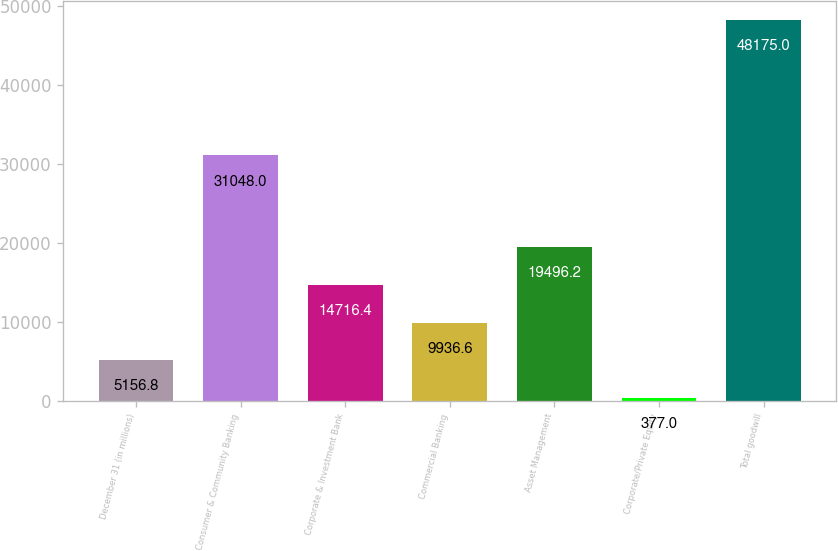<chart> <loc_0><loc_0><loc_500><loc_500><bar_chart><fcel>December 31 (in millions)<fcel>Consumer & Community Banking<fcel>Corporate & Investment Bank<fcel>Commercial Banking<fcel>Asset Management<fcel>Corporate/Private Equity<fcel>Total goodwill<nl><fcel>5156.8<fcel>31048<fcel>14716.4<fcel>9936.6<fcel>19496.2<fcel>377<fcel>48175<nl></chart> 